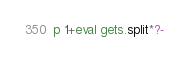Convert code to text. <code><loc_0><loc_0><loc_500><loc_500><_Ruby_>p 1+eval gets.split*?-</code> 